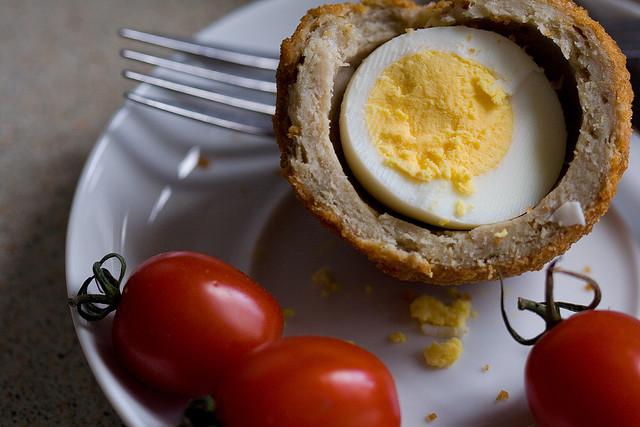How was the egg prepared?
Answer briefly. Hard boiled. Is there an egg sandwich on the plate?
Quick response, please. Yes. What are the red objects on the plate?
Quick response, please. Tomatoes. 